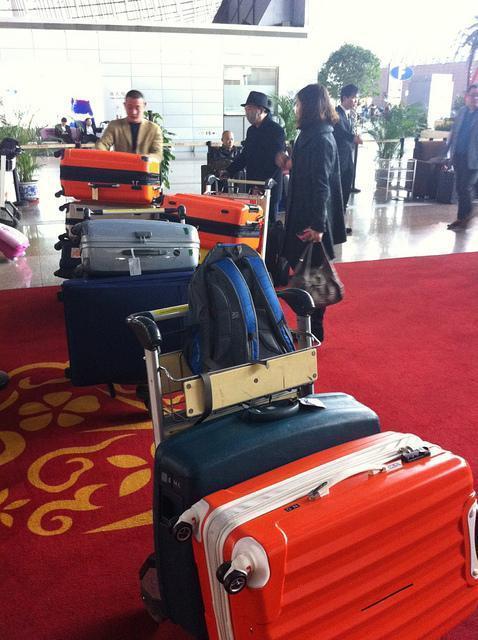How many people are there?
Give a very brief answer. 4. How many suitcases are there?
Give a very brief answer. 6. How many umbrellas are in the photo?
Give a very brief answer. 0. 